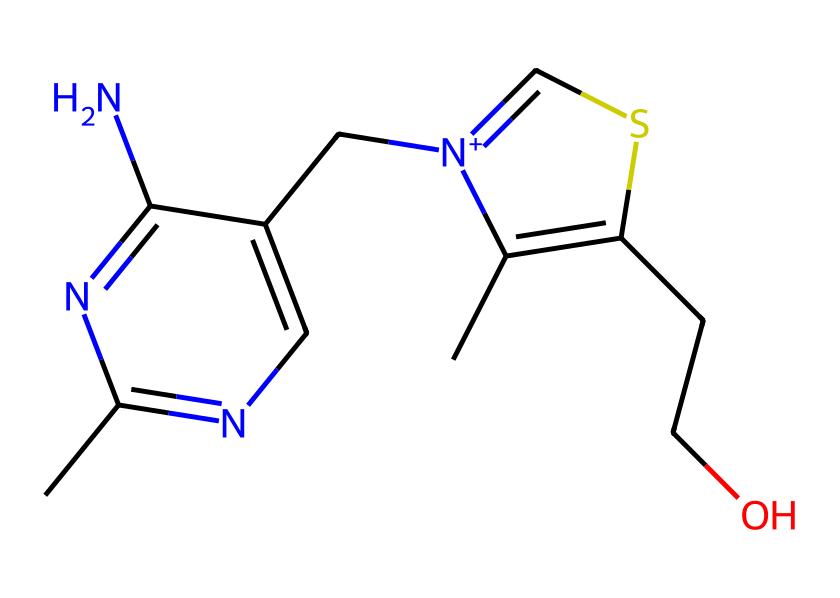What is the total number of nitrogen atoms in this chemical? By examining the SMILES representation, we can count the occurrences of 'n' (lowercase) which represents nitrogen in the structure. There are four occurrences of 'n'.
Answer: four How many sulfur atoms are present in thiamine? The SMILES depiction includes one occurrence of 's', indicating the presence of a single sulfur atom in the molecule.
Answer: one What is the significance of the sulfur atom in thiamine? The sulfur atom in thiamine is part of the thiazole ring, which is essential for the vitamin's function in metabolism.
Answer: metabolic function Which element in thiamine is responsible for its classification as a sulfur-containing vitamin? The presence of sulfur in the chemical structure classifies thiamine as a sulfur-containing vitamin.
Answer: sulfur How many carbon atoms are present in this chemical structure? Counting the occurrences of 'C' and 'c' in the SMILES, we find that there are a total of 8 carbon atoms in thiamine.
Answer: eight What type of compound is thiamine? Thiamine is classified as a water-soluble vitamin due to its solubility characteristics, significantly affecting its role in human nutrition.
Answer: water-soluble vitamin Which functional groups are indicated in the structure of thiamine? The presence of amino (-NH2) and hydroxyl (-OH) groups can be identified from the structure, highlighting its functional diversity.
Answer: amino and hydroxyl groups 